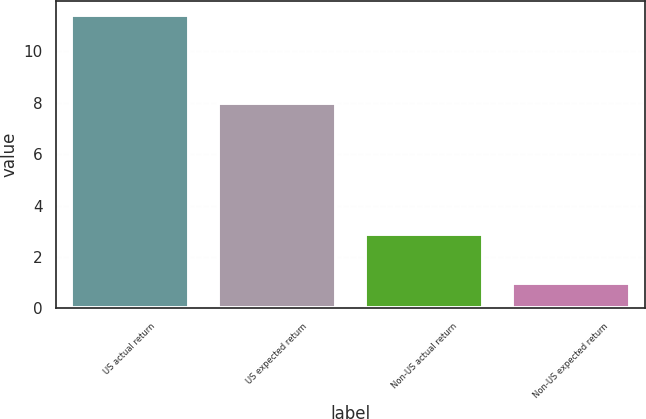Convert chart to OTSL. <chart><loc_0><loc_0><loc_500><loc_500><bar_chart><fcel>US actual return<fcel>US expected return<fcel>Non-US actual return<fcel>Non-US expected return<nl><fcel>11.4<fcel>8<fcel>2.9<fcel>1<nl></chart> 